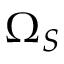Convert formula to latex. <formula><loc_0><loc_0><loc_500><loc_500>\Omega _ { S }</formula> 